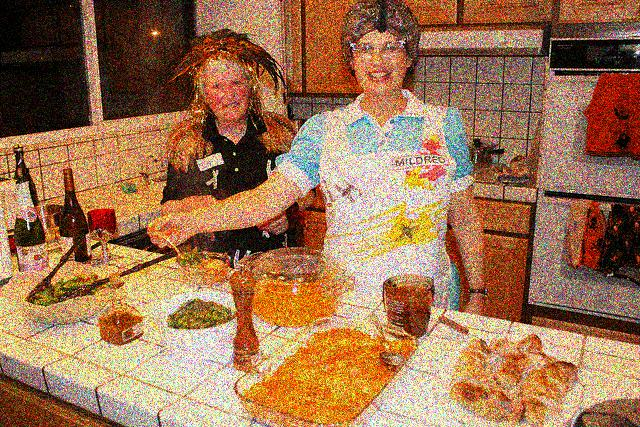What attire are the women wearing, and what does it suggest about the setting? Both women are wearing aprons, which is appropriate attire for cooking and implies that they are actively involved in preparing food. One apron features a logo or text, which could suggest a special occasion or that it is a souvenir from a place or event. Their casual and protective clothing indicates they are in a comfortable setting, likely preparing a meal in a home kitchen. 